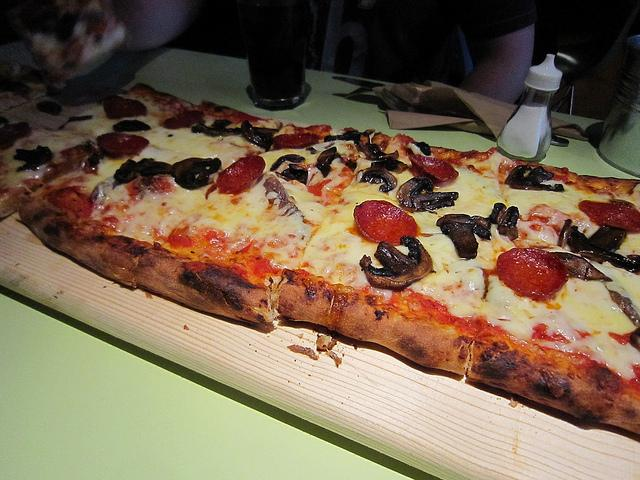What ingredient used as a veg toppings of the pizza?

Choices:
A) celery
B) pasta
C) mushroom
D) capsicum mushroom 